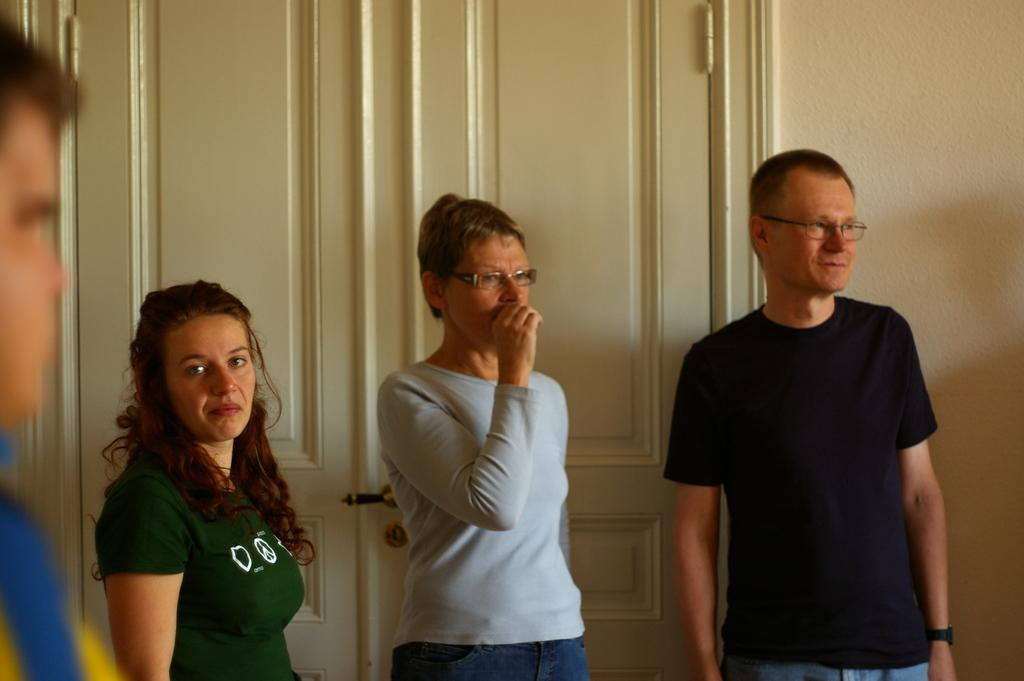What is happening in the image? There are people standing in the image. What can be seen in the background of the image? There is a wall in the background of the image. Can you describe the wall in the background? There is a door in the wall in the background of the image. What type of music can be heard coming from the battle in the image? There is no battle or music present in the image; it features people standing in front of a wall with a door. 